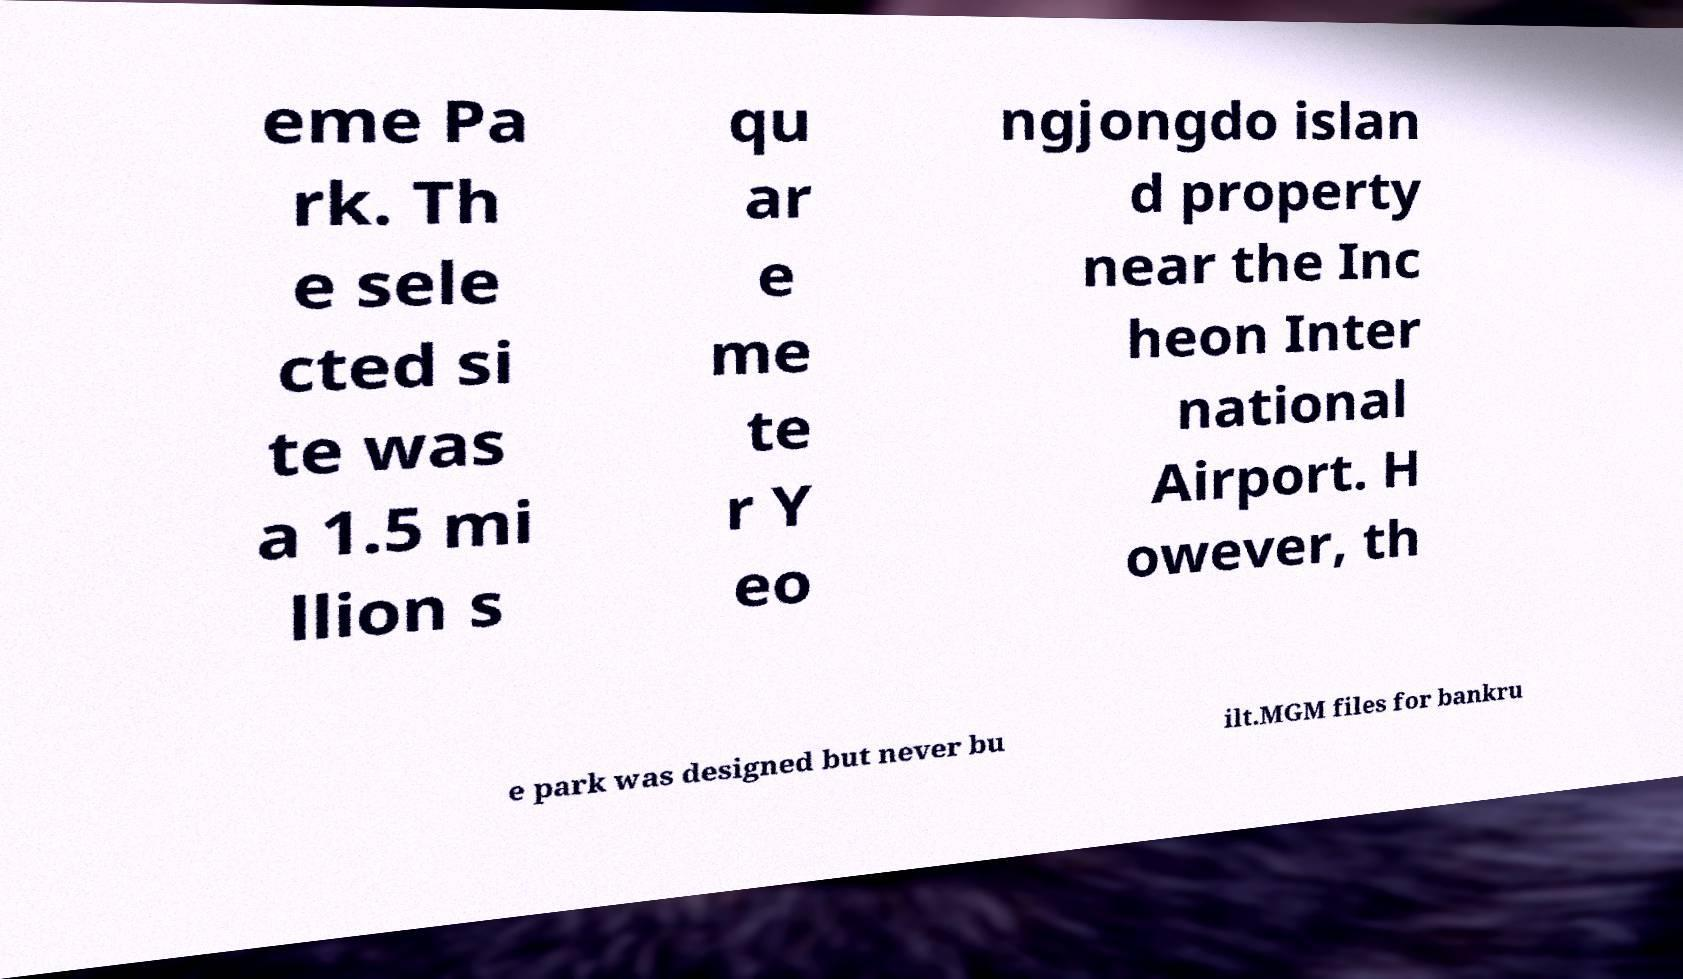Can you accurately transcribe the text from the provided image for me? eme Pa rk. Th e sele cted si te was a 1.5 mi llion s qu ar e me te r Y eo ngjongdo islan d property near the Inc heon Inter national Airport. H owever, th e park was designed but never bu ilt.MGM files for bankru 